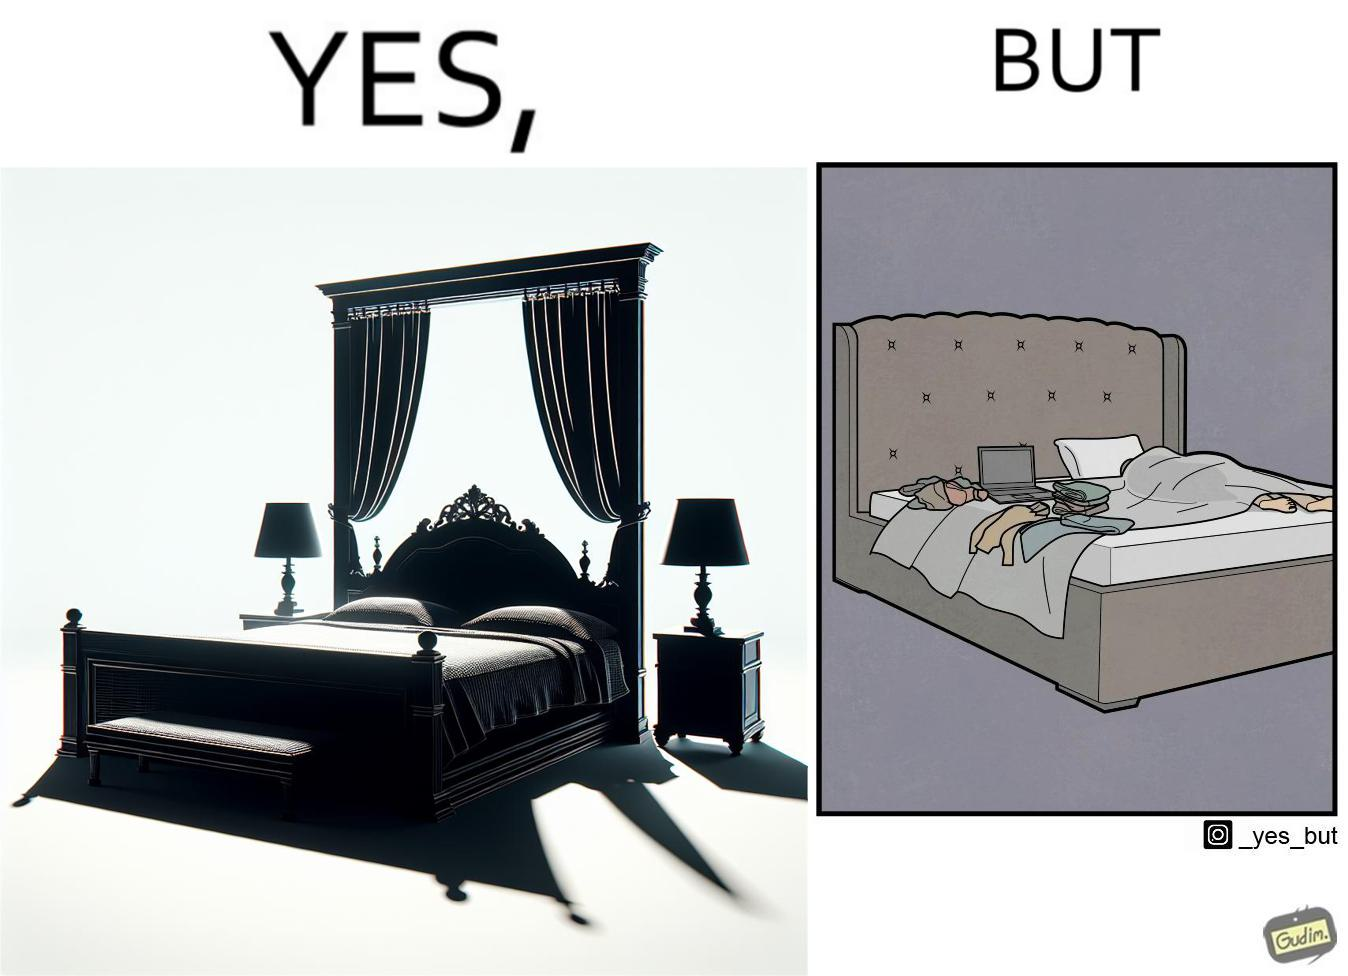What does this image depict? Although the person has purchased a king size bed, but only less than half of the space is used by the person for sleeping. 